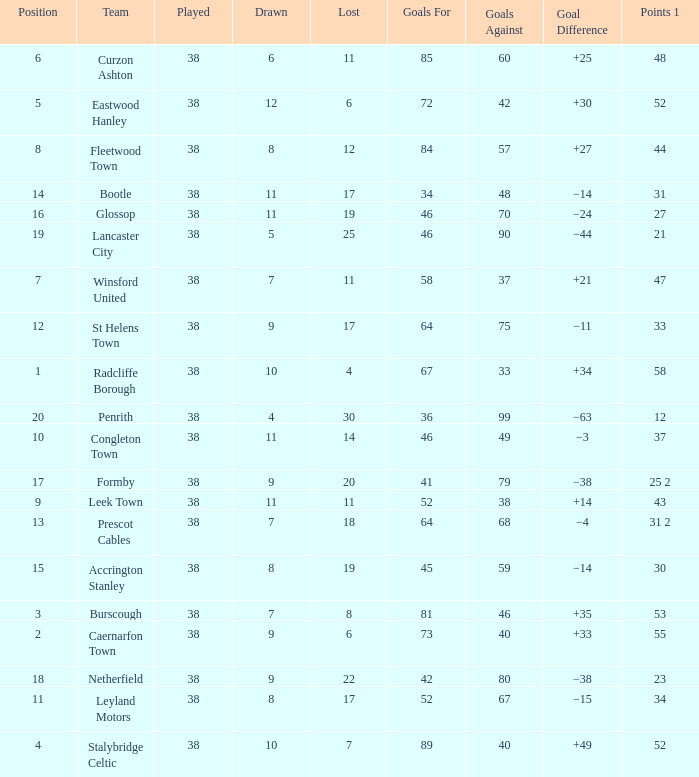WHAT IS THE LOST WITH A DRAWN 11, FOR LEEK TOWN? 11.0. 